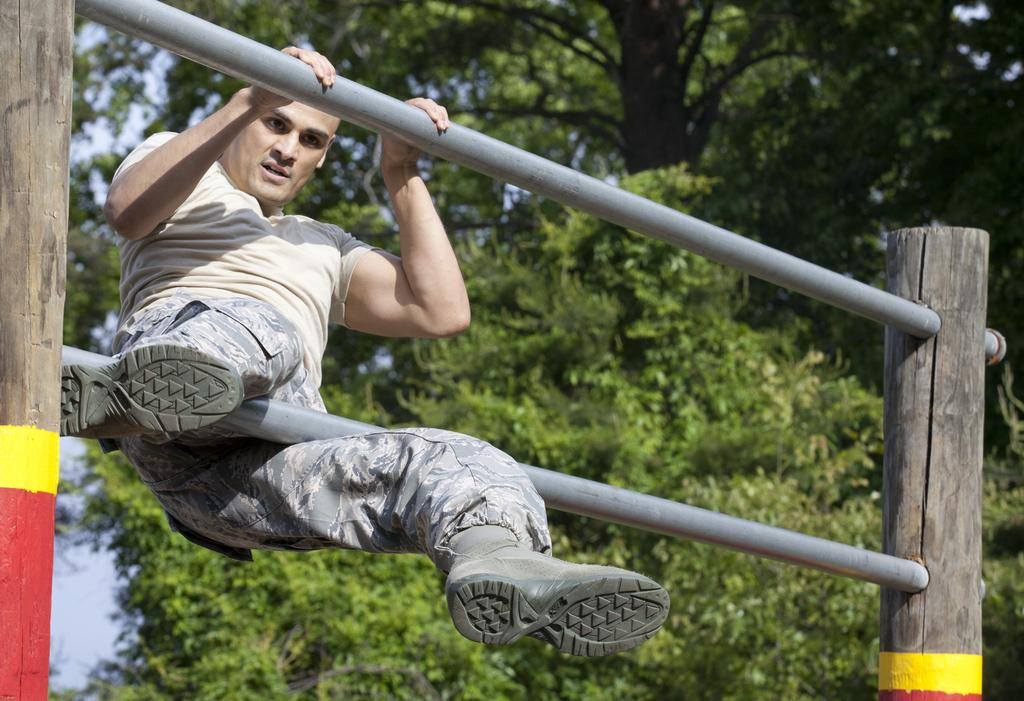Who is the main subject in the image? There is a man in the image. What is the man holding in the image? The man is holding a pole in the image. How is the man positioned in the image? The man is in the air in the image. What can be seen in the background of the image? There are trees and the sky visible in the background of the image. What type of wool is the man wearing in the image? There is no wool visible in the image, as the man is not wearing any clothing. Can you tell me how many parents are present in the image? There are no parents present in the image, as it only features a man holding a pole in the air. 